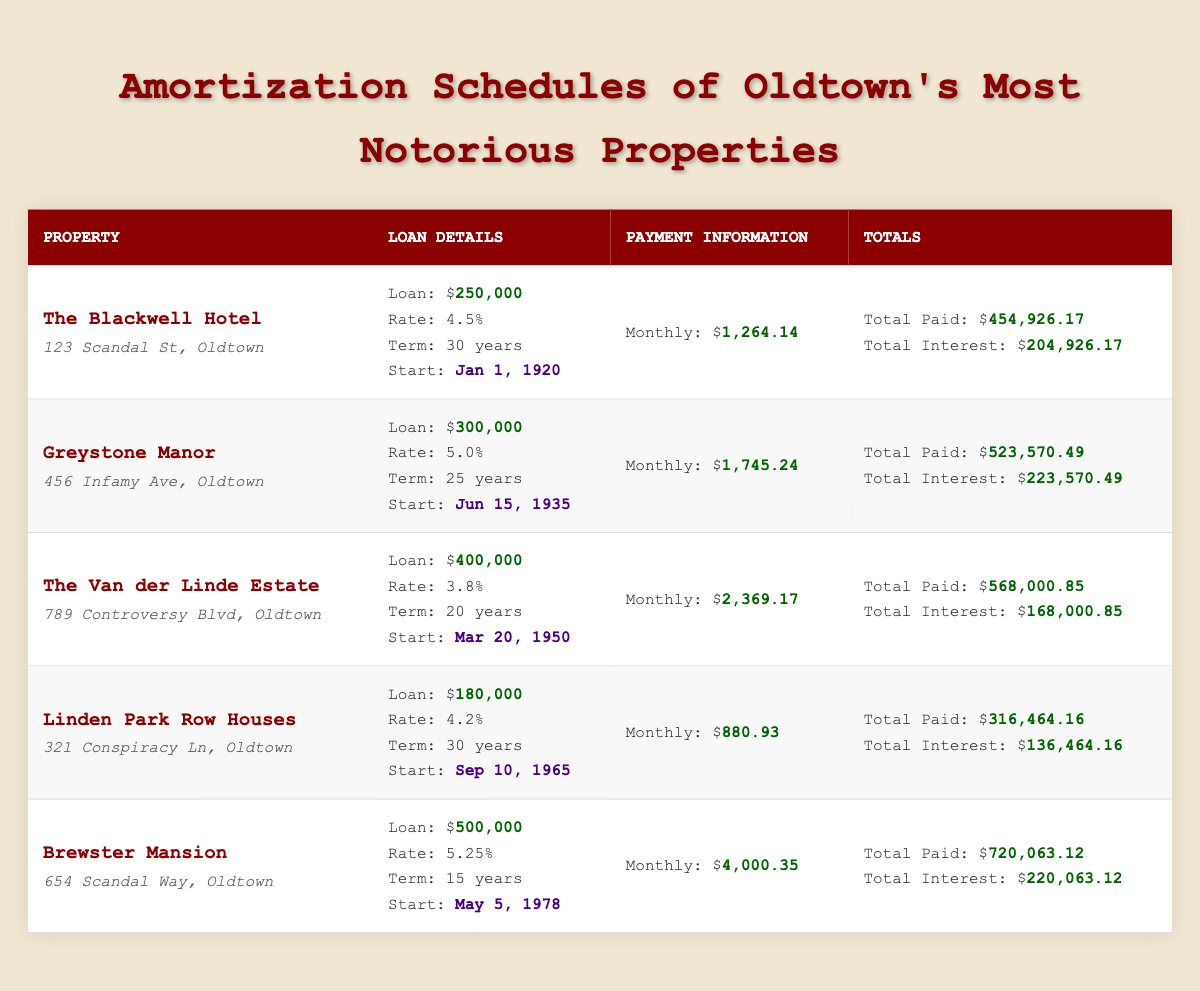What is the loan amount for Brewster Mansion? The table states the loan amount listed under Brewster Mansion as $500,000.
Answer: 500,000 Which property has the highest total interest paid? By examining the "Total Interest" column, Brewster Mansion shows $220,063.12, which is greater than the totals for the other properties.
Answer: Brewster Mansion What is the monthly payment for The Van der Linde Estate? The "Monthly" payment for The Van der Linde Estate is specifically listed as $2,369.17 in the table.
Answer: 2,369.17 How much total interest is paid over all the properties combined? To find the total interest paid, we sum the values from the "Total Interest" column: 204926.17 + 223570.49 + 168000.85 + 136464.16 + 220063.12 = 1,063,024.79.
Answer: 1,063,024.79 Is the interest rate for Greystone Manor higher than that for The Blackwell Hotel? Greystone Manor has an interest rate of 5.0%, while The Blackwell Hotel has an interest rate of 4.5%. Since 5.0% is greater, the statement is true.
Answer: Yes What is the difference in total paid between The Blackwell Hotel and Linde Park Row Houses? The total paid for The Blackwell Hotel is $454,926.17 and for Linden Park Row Houses, it is $316,464.16. The difference is calculated as $454,926.17 - $316,464.16 = $138,462.01.
Answer: 138,462.01 Which property has the longest loan term? The longest loan term listed in the table is 30 years for both The Blackwell Hotel and Linden Park Row Houses as denoted in the "Term" column.
Answer: The Blackwell Hotel and Linden Park Row Houses How many total years have passed since the start date for Brewster Mansion until now? Brewster Mansion's start date is May 5, 1978. From that date to now (2023) is 2023 - 1978 = 45 years.
Answer: 45 years Which property was financed with the smallest loan amount? The smallest loan amount in the table is $180,000, which belongs to the Linden Park Row Houses.
Answer: Linden Park Row Houses 